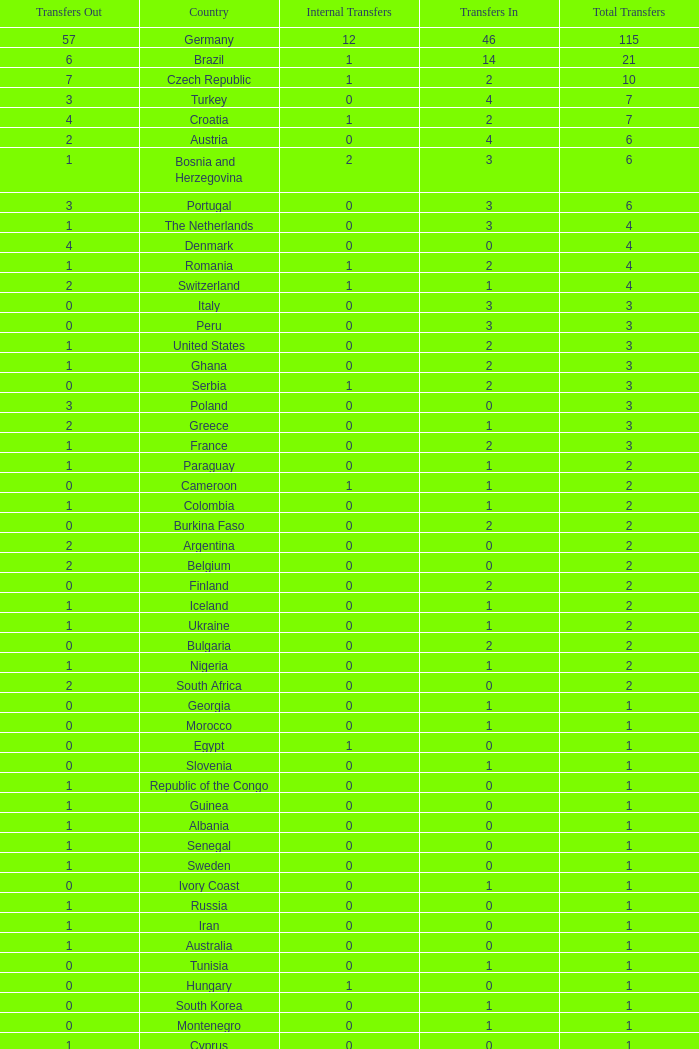What are the Transfers out for Peru? 0.0. 